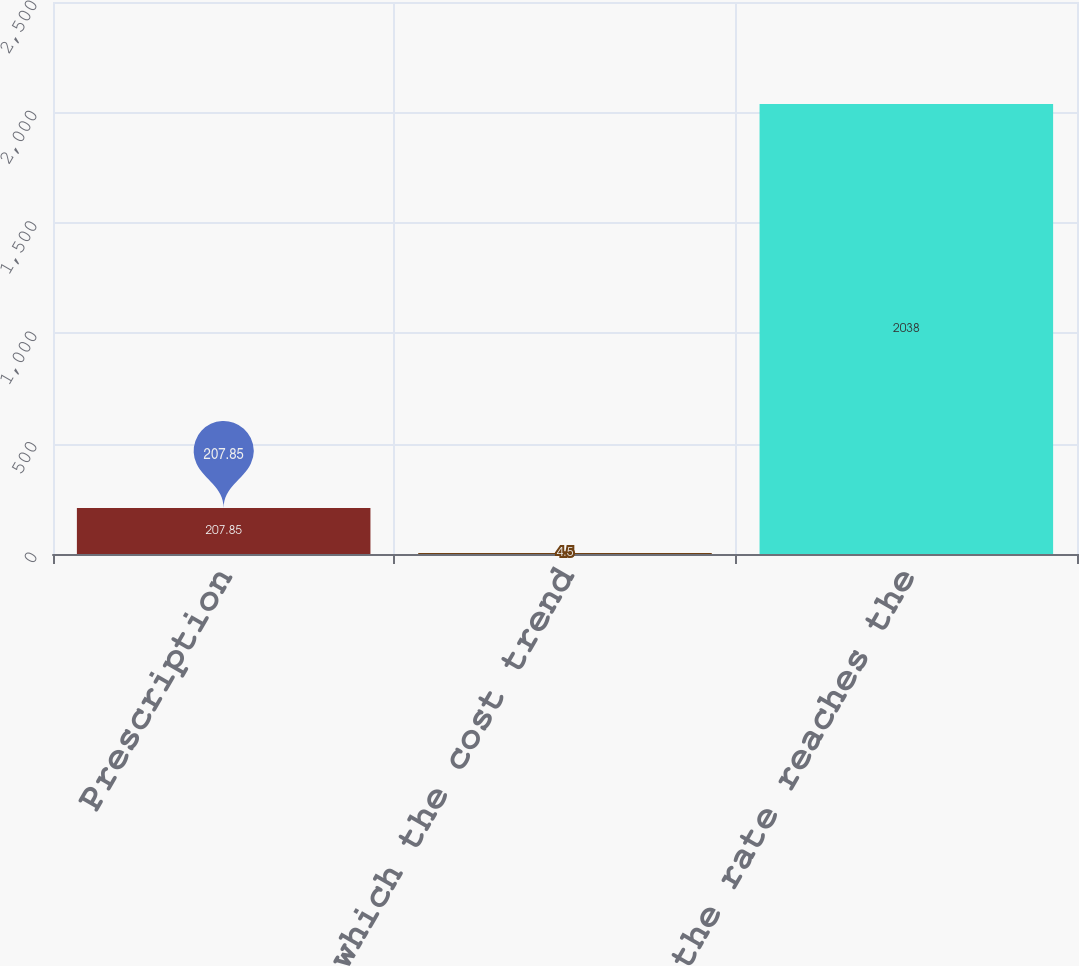Convert chart. <chart><loc_0><loc_0><loc_500><loc_500><bar_chart><fcel>Prescription<fcel>Rate to which the cost trend<fcel>Year that the rate reaches the<nl><fcel>207.85<fcel>4.5<fcel>2038<nl></chart> 